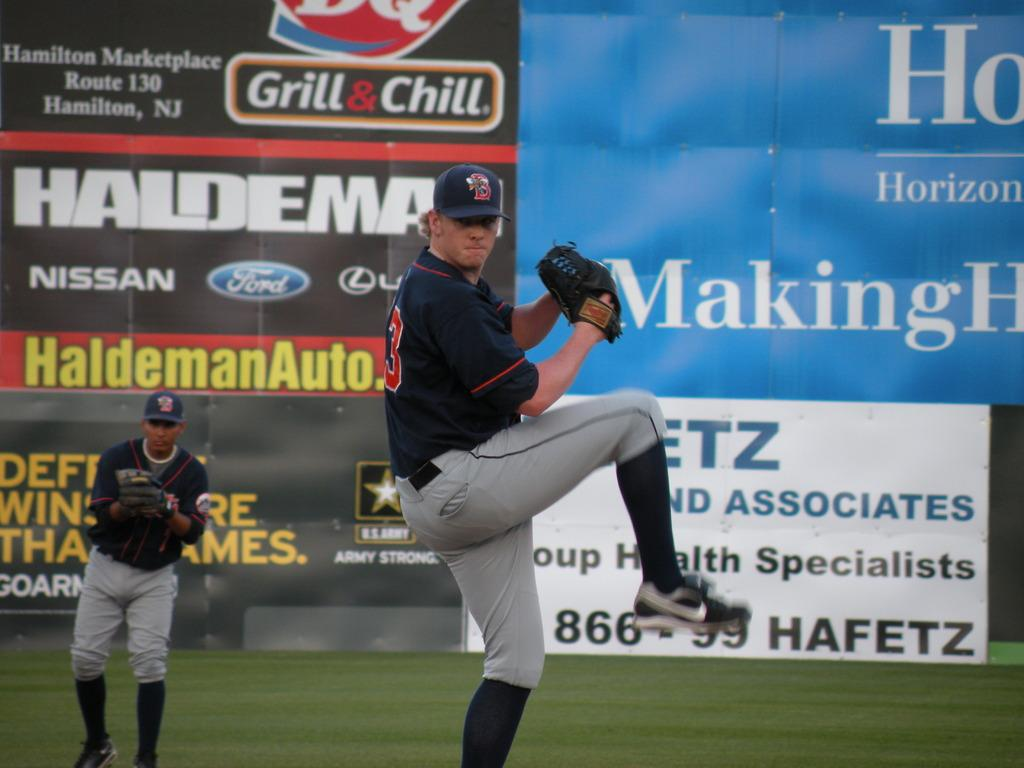Provide a one-sentence caption for the provided image. the word Making is on the ad in the outfie;d. 